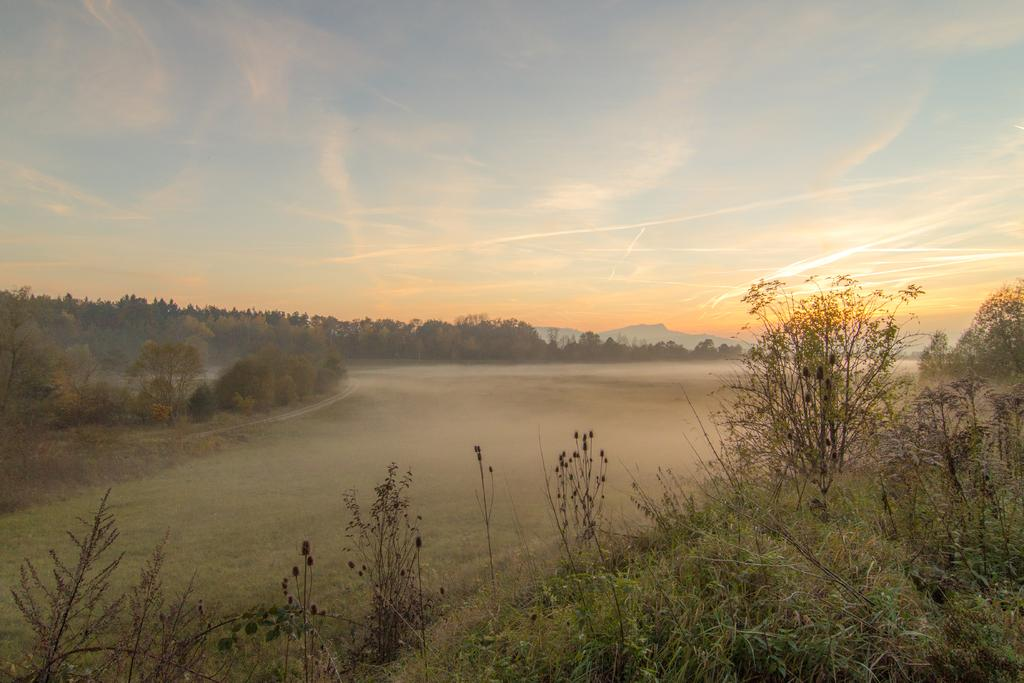What type of vegetation can be seen in the image? There are plants and trees in the image. What can be seen in the background of the image? There are hills in the background of the image. What is visible in the sky in the image? The sky is visible in the image, and clouds are present. What language are the plants speaking in the image? Plants do not speak any language, so this cannot be determined from the image. 